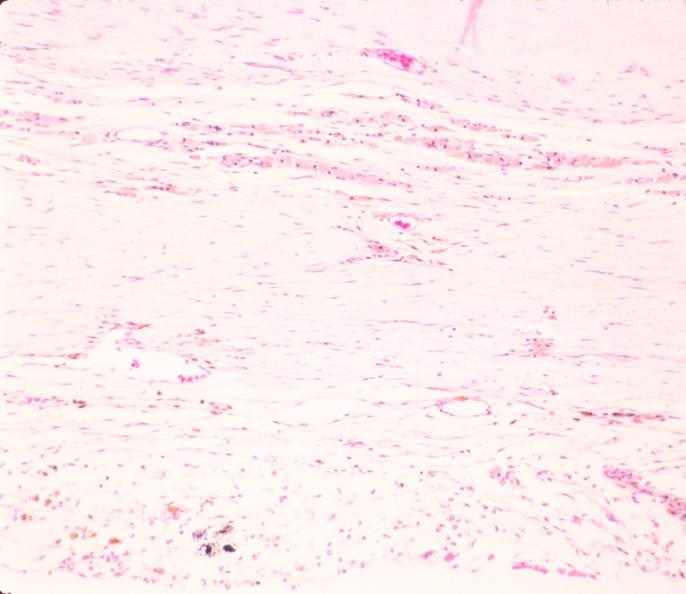does this image show brain, infarct due to ruptured saccular aneurysm and thrombosis of right middle cerebral artery?
Answer the question using a single word or phrase. Yes 